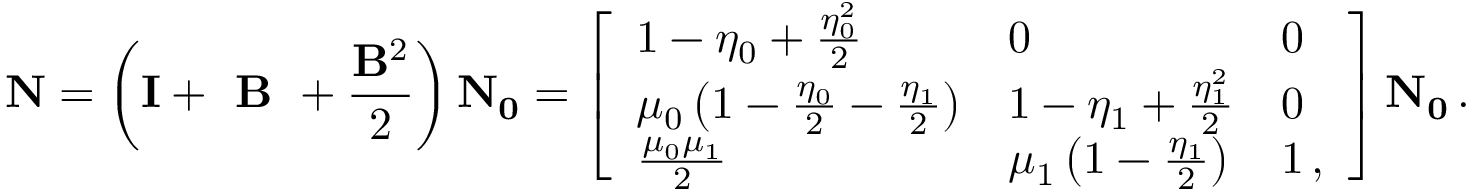<formula> <loc_0><loc_0><loc_500><loc_500>N = \left ( I + B + \frac { B ^ { 2 } } { 2 } \right ) N _ { 0 } = \left [ \begin{array} { l l l } { 1 - \eta _ { 0 } + \frac { \eta _ { 0 } ^ { 2 } } { 2 } } & { 0 } & { 0 } \\ { \mu _ { 0 } \left ( 1 - \frac { \eta _ { 0 } } { 2 } - \frac { \eta _ { 1 } } { 2 } \right ) } & { 1 - \eta _ { 1 } + \frac { \eta _ { 1 } ^ { 2 } } { 2 } } & { 0 } \\ { \frac { \mu _ { 0 } \mu _ { 1 } } { 2 } } & { \mu _ { 1 } \left ( 1 - \frac { \eta _ { 1 } } { 2 } \right ) } & { 1 \, , } \end{array} \right ] N _ { 0 } \, .</formula> 